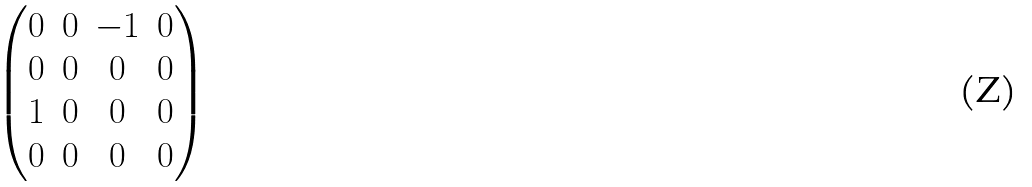Convert formula to latex. <formula><loc_0><loc_0><loc_500><loc_500>\begin{pmatrix} 0 & 0 & - 1 & 0 \\ 0 & 0 & 0 & 0 \\ 1 & 0 & 0 & 0 \\ 0 & 0 & 0 & 0 \end{pmatrix}</formula> 